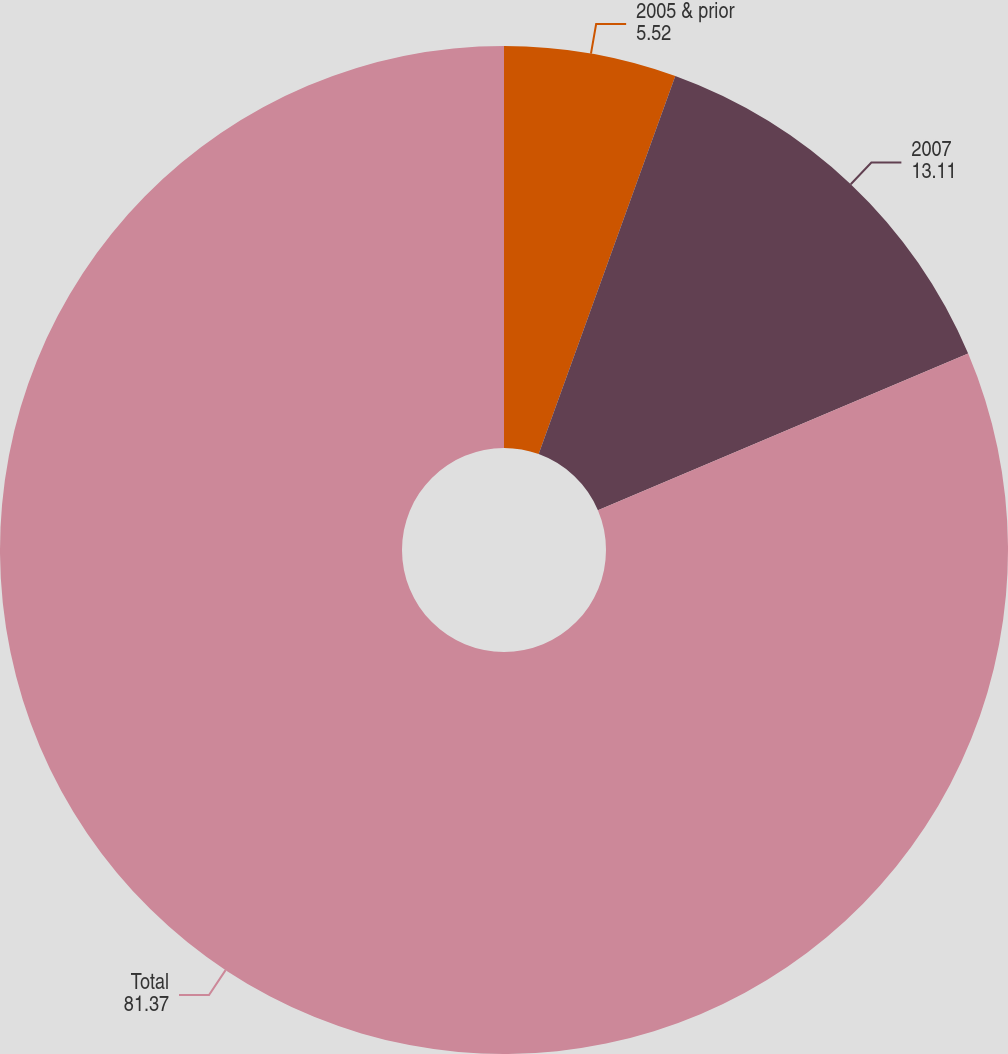<chart> <loc_0><loc_0><loc_500><loc_500><pie_chart><fcel>2005 & prior<fcel>2007<fcel>Total<nl><fcel>5.52%<fcel>13.11%<fcel>81.37%<nl></chart> 